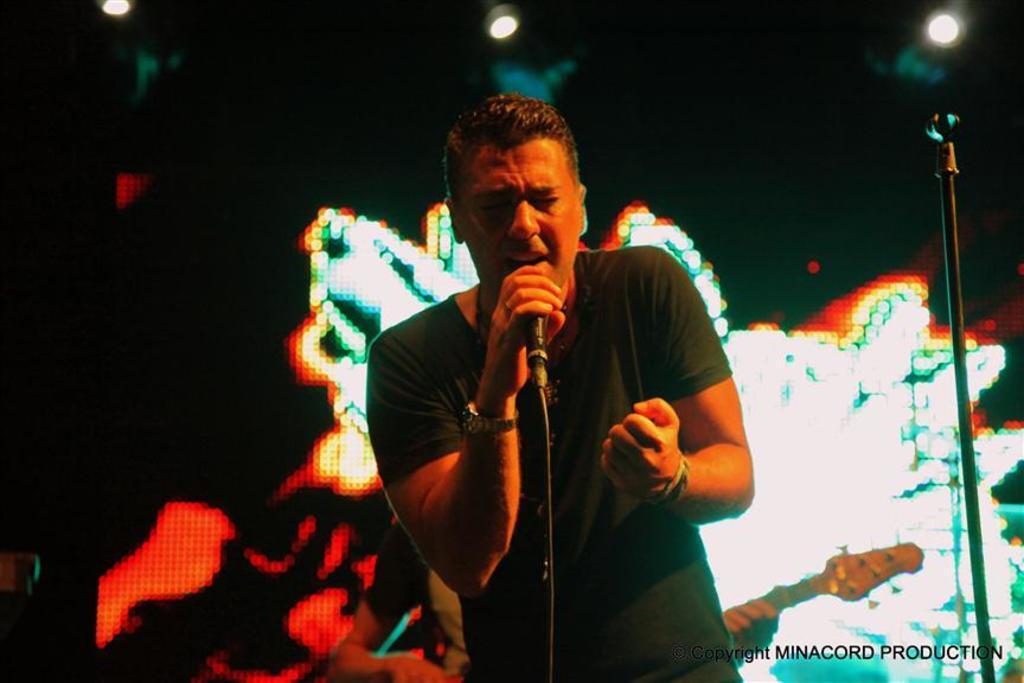How would you summarize this image in a sentence or two? In this image we can see a man singing on a microphone. He is wearing a T-shirt and here we can see the watch on right hand. Here we can see the hand band on his left hand. In the background, we can see a person playing a guitar. Here we can see the lightning arrangement on the roof. 